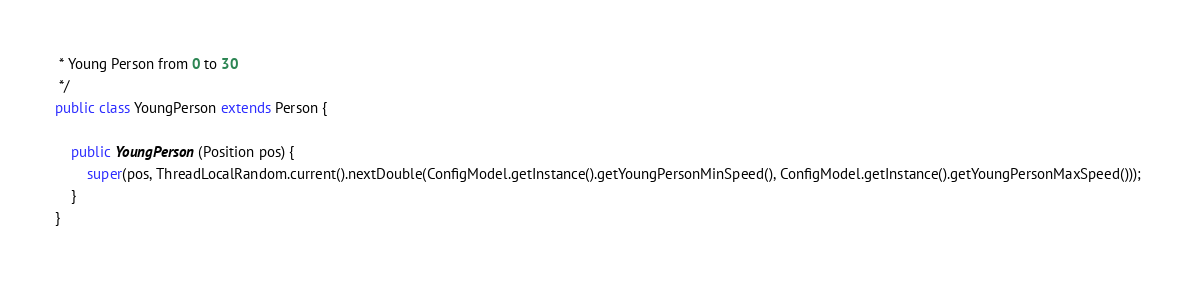<code> <loc_0><loc_0><loc_500><loc_500><_Java_> * Young Person from 0 to 30
 */
public class YoungPerson extends Person {

	public YoungPerson(Position pos) {
		super(pos, ThreadLocalRandom.current().nextDouble(ConfigModel.getInstance().getYoungPersonMinSpeed(), ConfigModel.getInstance().getYoungPersonMaxSpeed()));
	}
}
</code> 